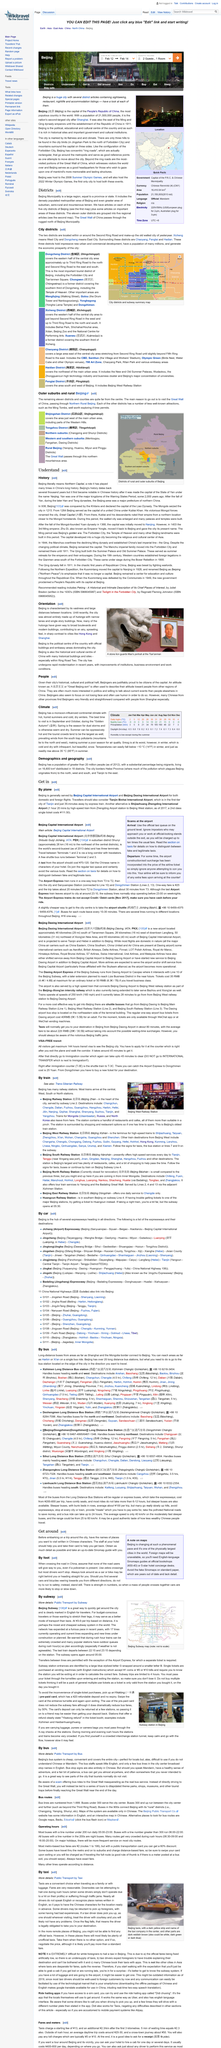Identify some key points in this picture. The subway opens at 05:00 and closes between 22:15 and 23:15. The Republic of China was established in 1911. When a large group of people cross the road at the same time, cars are more likely to stop or slow down. I require a specific type of guide that I can take with me, and I have chosen an English language sinomap guide for this purpose. The range of the cost of a trip is between 3 and 9 per trip. 